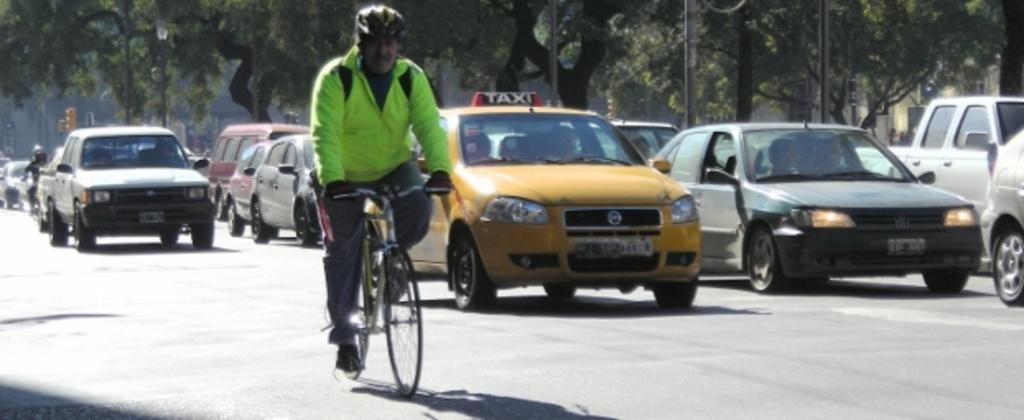<image>
Describe the image concisely. The taxi's last two digits of the license plate are 44. 